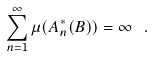<formula> <loc_0><loc_0><loc_500><loc_500>\sum _ { n = 1 } ^ { \infty } \mu ( A ^ { * } _ { n } ( B ) ) = \infty \ .</formula> 